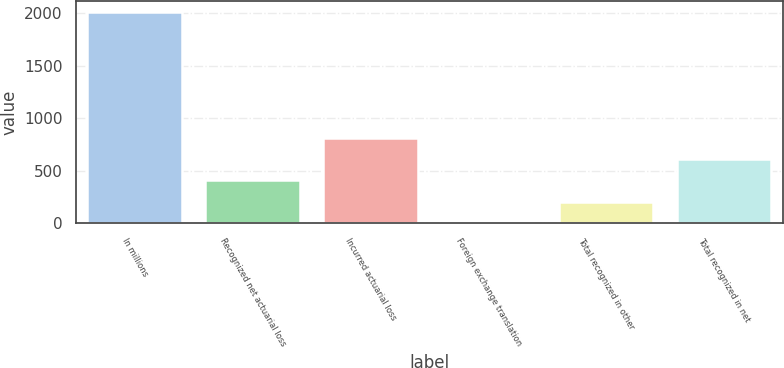Convert chart to OTSL. <chart><loc_0><loc_0><loc_500><loc_500><bar_chart><fcel>In millions<fcel>Recognized net actuarial loss<fcel>Incurred actuarial loss<fcel>Foreign exchange translation<fcel>Total recognized in other<fcel>Total recognized in net<nl><fcel>2015<fcel>408.6<fcel>810.2<fcel>7<fcel>207.8<fcel>609.4<nl></chart> 